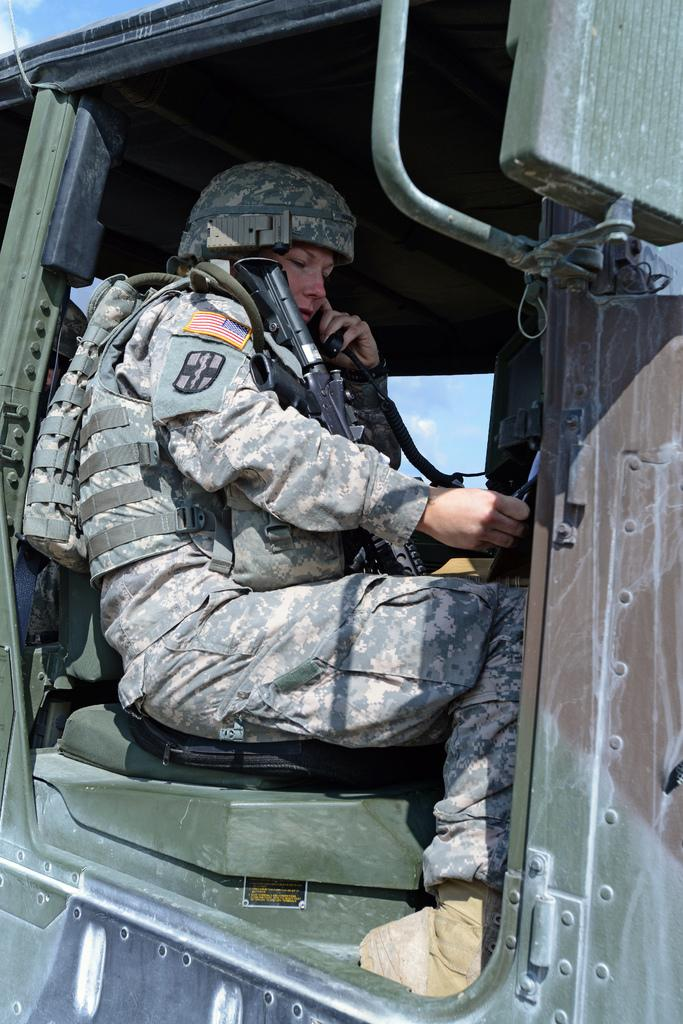What is the person in the image doing? The person is sitting in a vehicle in the image. What type of clothing is the person wearing? The person is wearing an army dress. What is the person holding in the image? The person is holding a weapon. What is the person in the image trying to smash with their weapon? There is no indication in the image that the person is trying to smash anything with their weapon. 